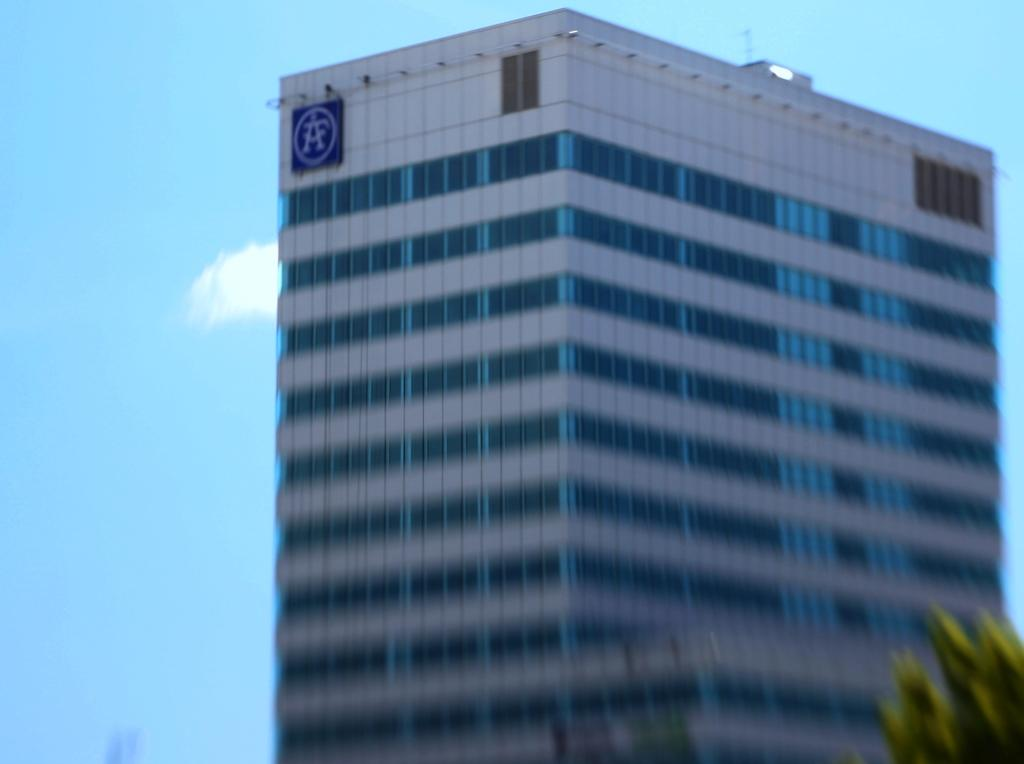What type of structure is present in the image? There is a building in the image. What can be seen in the background of the building? The sky is visible in the backside of the building. Is there a river flowing near the building in the image? There is no river visible in the image; only the building and the sky are present. What type of rice can be seen being cooked in the building? There is no rice or any indication of cooking in the image; it only features a building and the sky. 